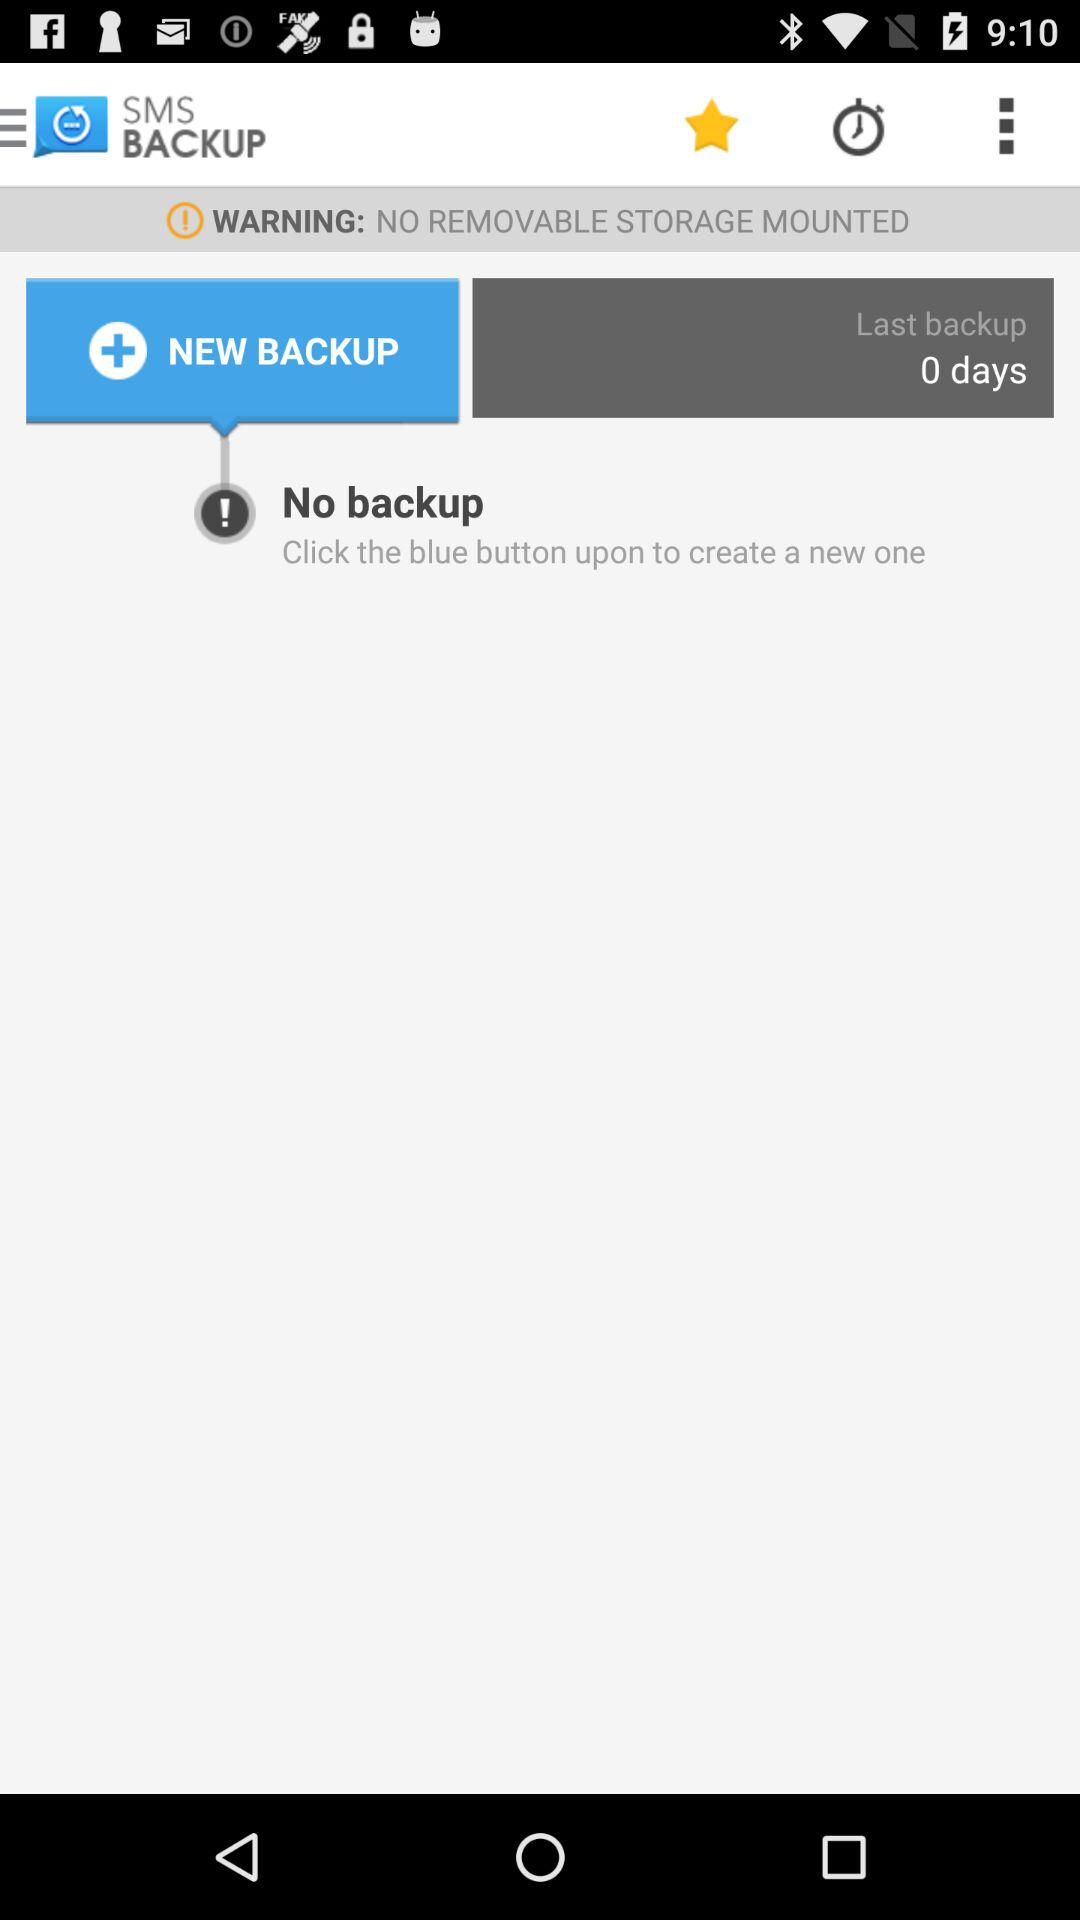How many days has it been since the last backup?
Answer the question using a single word or phrase. 0 days 